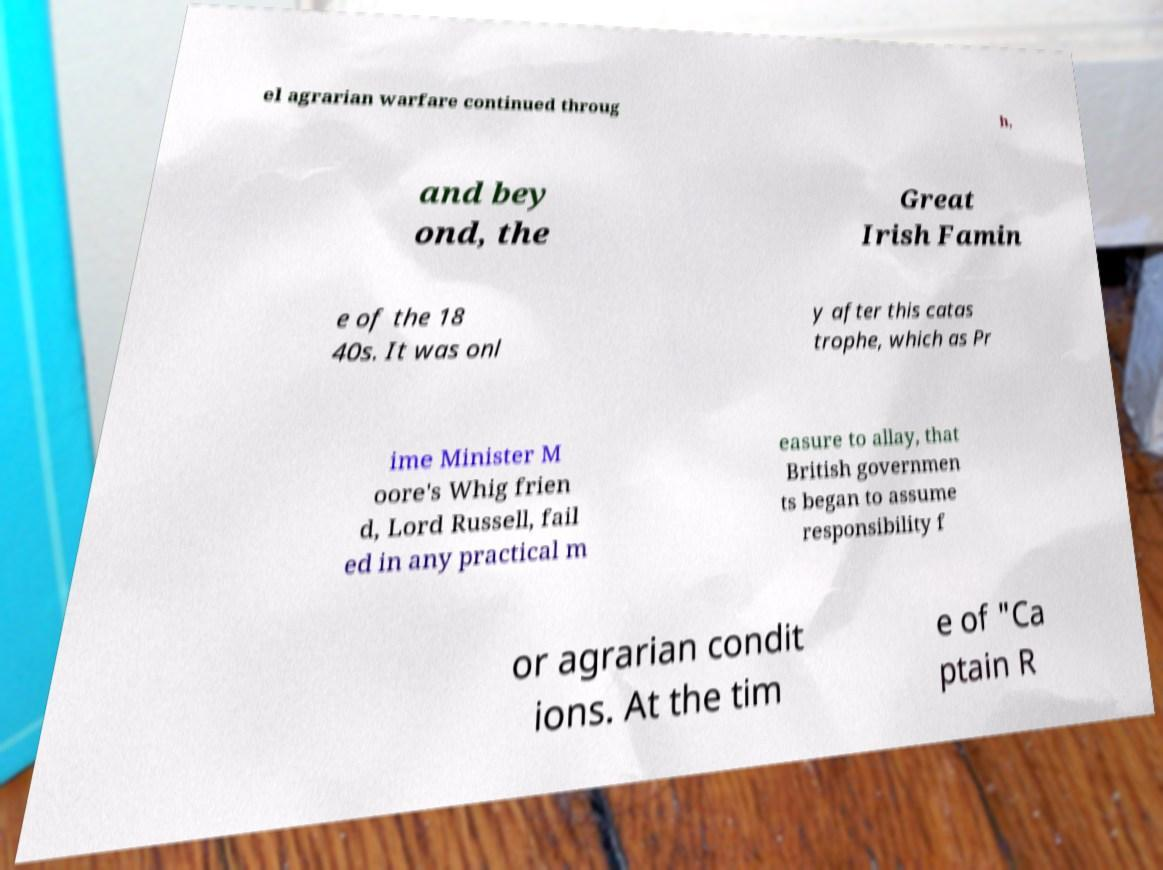For documentation purposes, I need the text within this image transcribed. Could you provide that? el agrarian warfare continued throug h, and bey ond, the Great Irish Famin e of the 18 40s. It was onl y after this catas trophe, which as Pr ime Minister M oore's Whig frien d, Lord Russell, fail ed in any practical m easure to allay, that British governmen ts began to assume responsibility f or agrarian condit ions. At the tim e of "Ca ptain R 